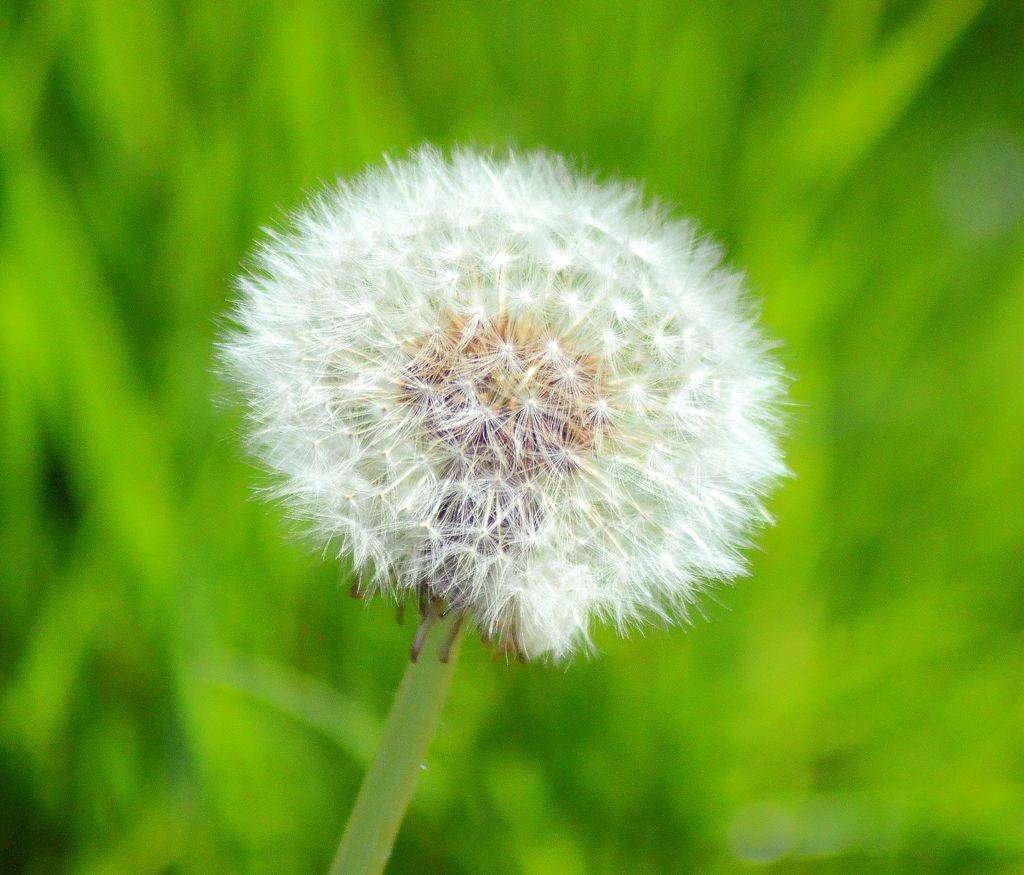What is the main subject of the image? There is a flower in the image. Can you describe the color of the flower? The flower is white in color. What can be observed about the background of the image? The background of the image is blurred. How does the flower grant wishes in the image? The flower does not grant wishes in the image, as it is a static image and not an interactive object. 